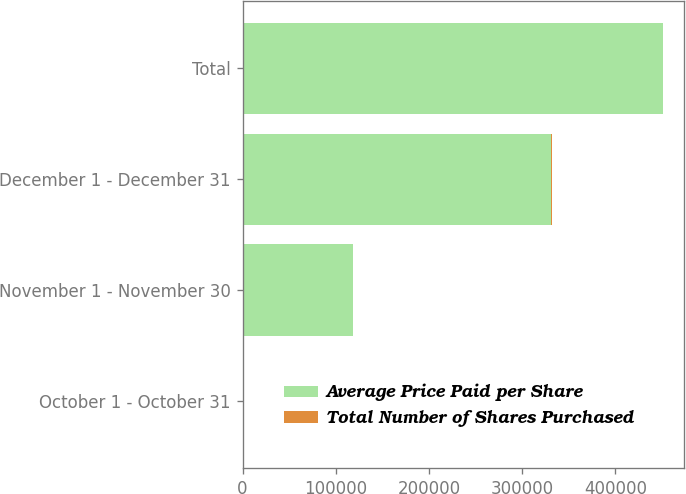Convert chart. <chart><loc_0><loc_0><loc_500><loc_500><stacked_bar_chart><ecel><fcel>October 1 - October 31<fcel>November 1 - November 30<fcel>December 1 - December 31<fcel>Total<nl><fcel>Average Price Paid per Share<fcel>1077<fcel>118940<fcel>331389<fcel>451406<nl><fcel>Total Number of Shares Purchased<fcel>63.22<fcel>60.62<fcel>60.59<fcel>60.61<nl></chart> 